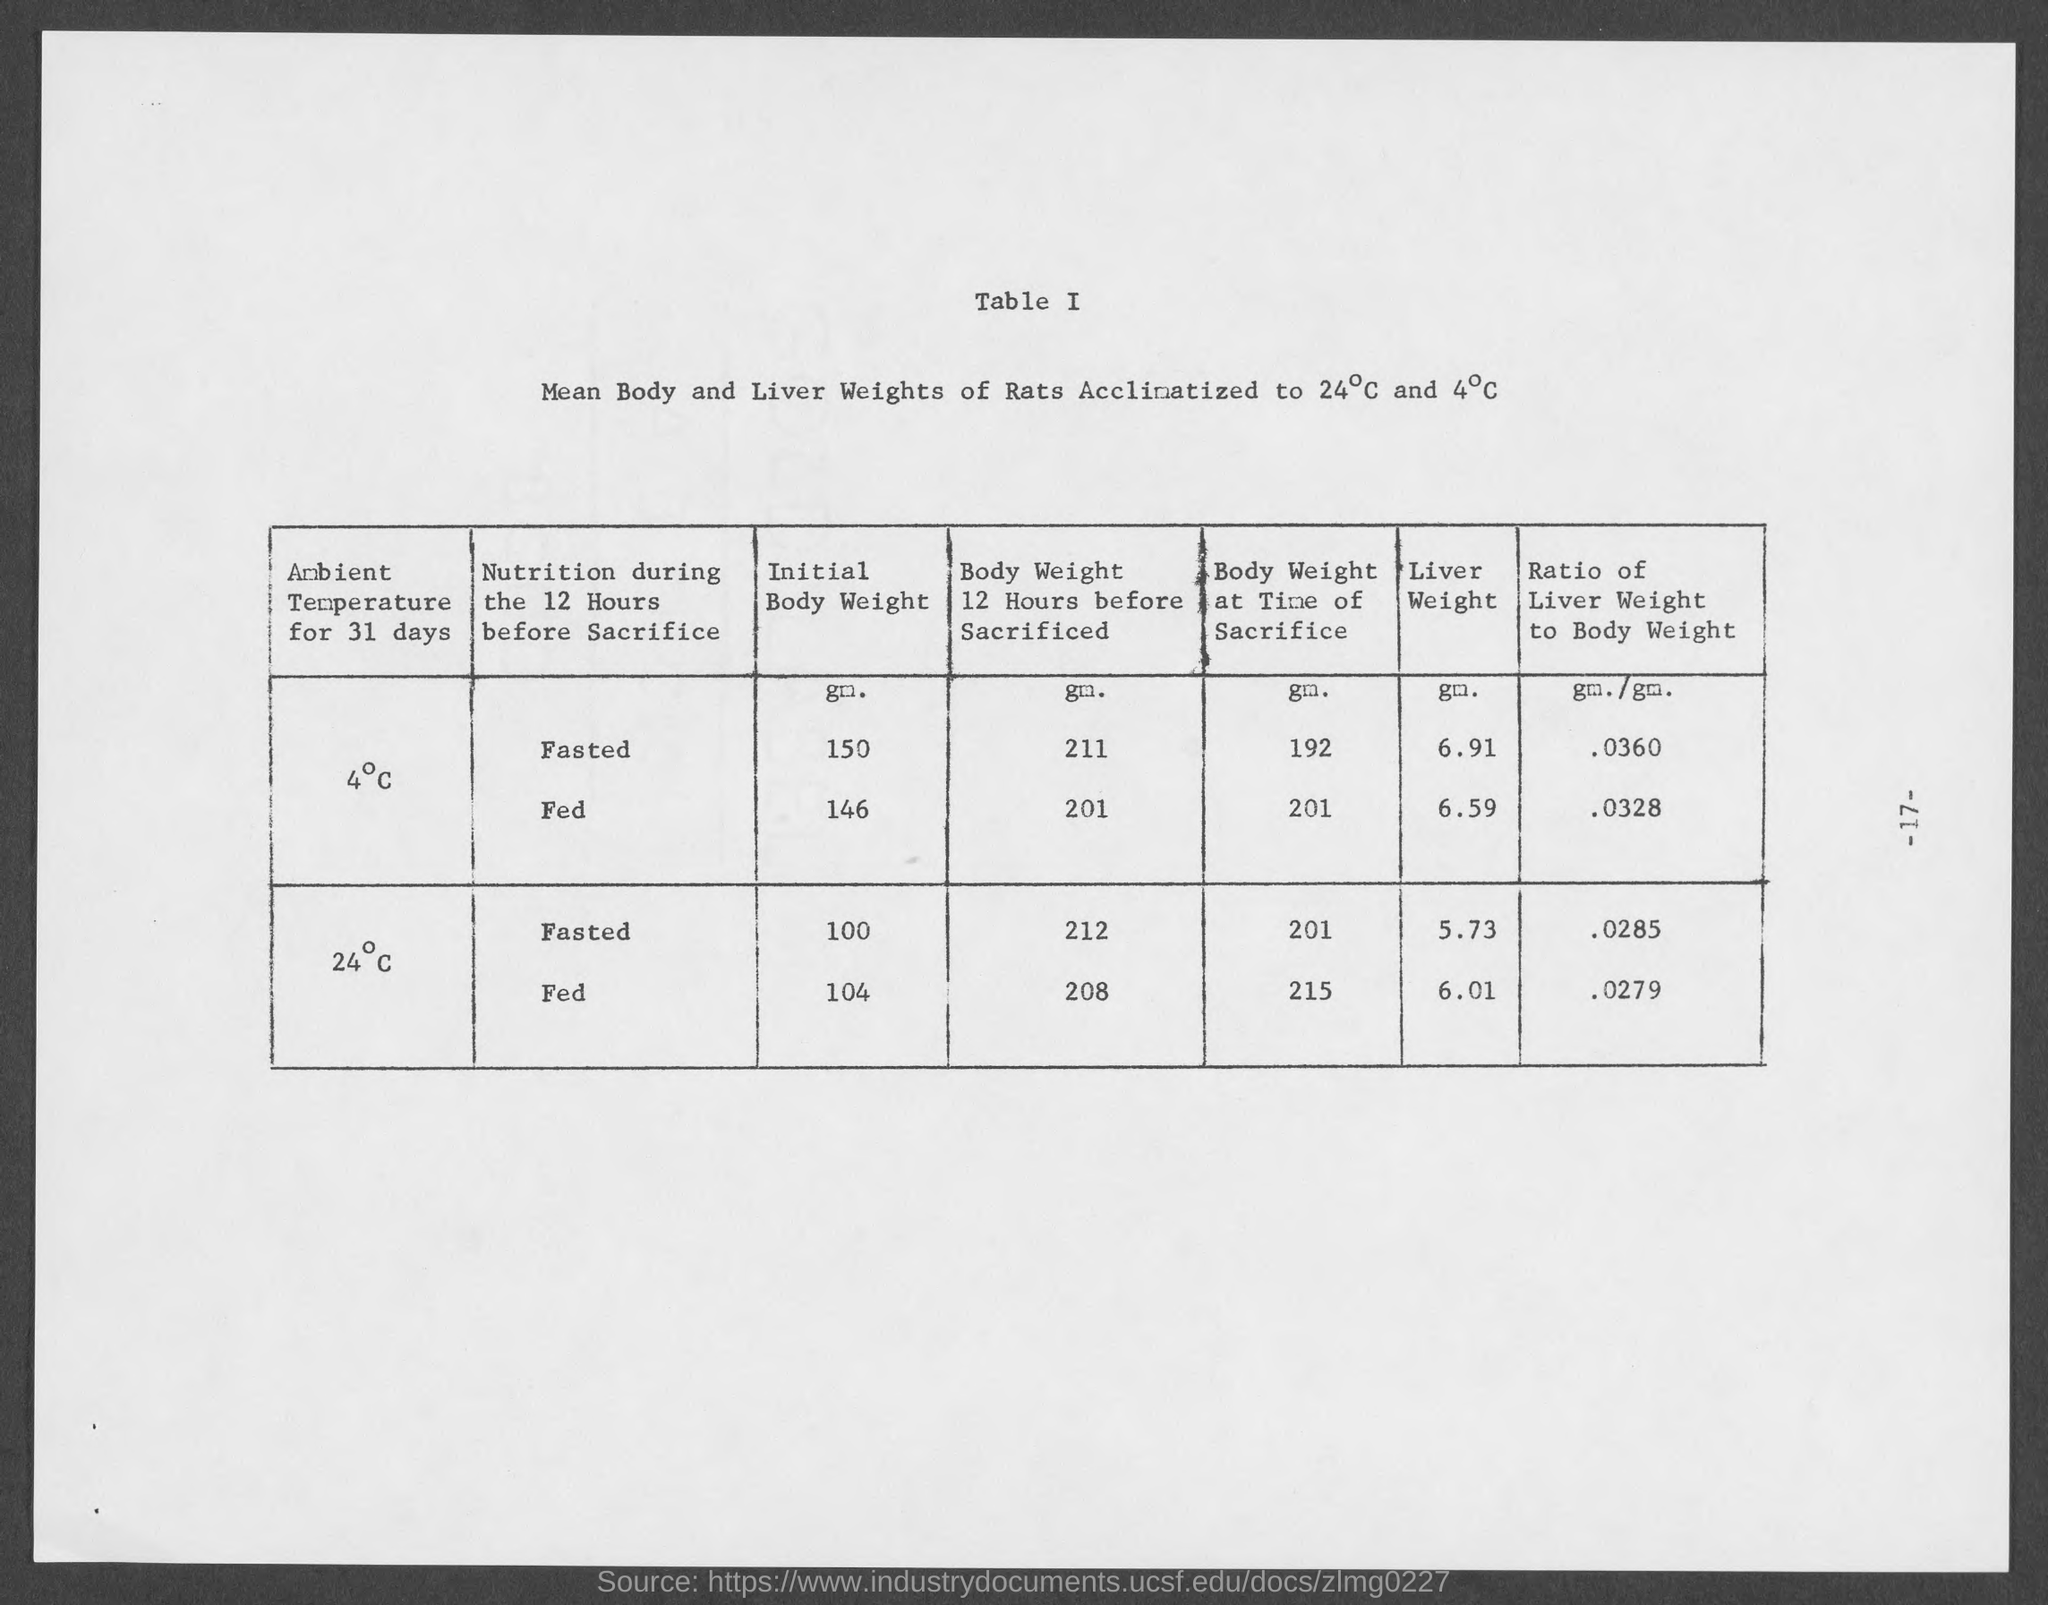What is the liver weight of rats (in gm) fasted during 12 hours before sacrifice, acclinatized to 4°C?
Your answer should be very brief. 6.91. What is the liver weight of rats (in gm) fed during 12 hours before sacrifice, acclinatized to 4°C?
Your answer should be compact. 6.59. What is the Ratio of liver weight to body weight of rats (gm./gm.) fed during 12 hours before sacrifice, acclinatized to 24°C?
Ensure brevity in your answer.  .0279. What is the Ratio of liver weight to body weight of rats (gm./gm.) fasted during 12 hours before sacrifice, acclinatized to 4°C?
Give a very brief answer. .0360. What is the Initial body weight (gm.) of rats fasted during 12 hours before sacrifice, acclinatized to 4°C?
Offer a terse response. 150. What is the Initial body weight (gm.) of rats fed during 12 hours before sacrifice, acclinatized to 24°C?
Keep it short and to the point. 104. 